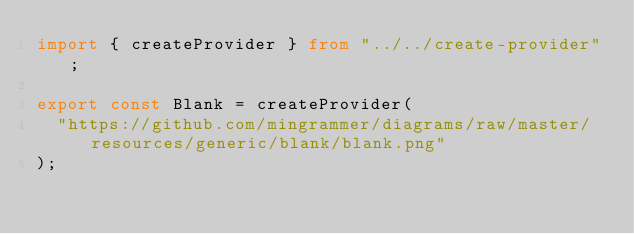<code> <loc_0><loc_0><loc_500><loc_500><_TypeScript_>import { createProvider } from "../../create-provider";

export const Blank = createProvider(
  "https://github.com/mingrammer/diagrams/raw/master/resources/generic/blank/blank.png"
);
</code> 